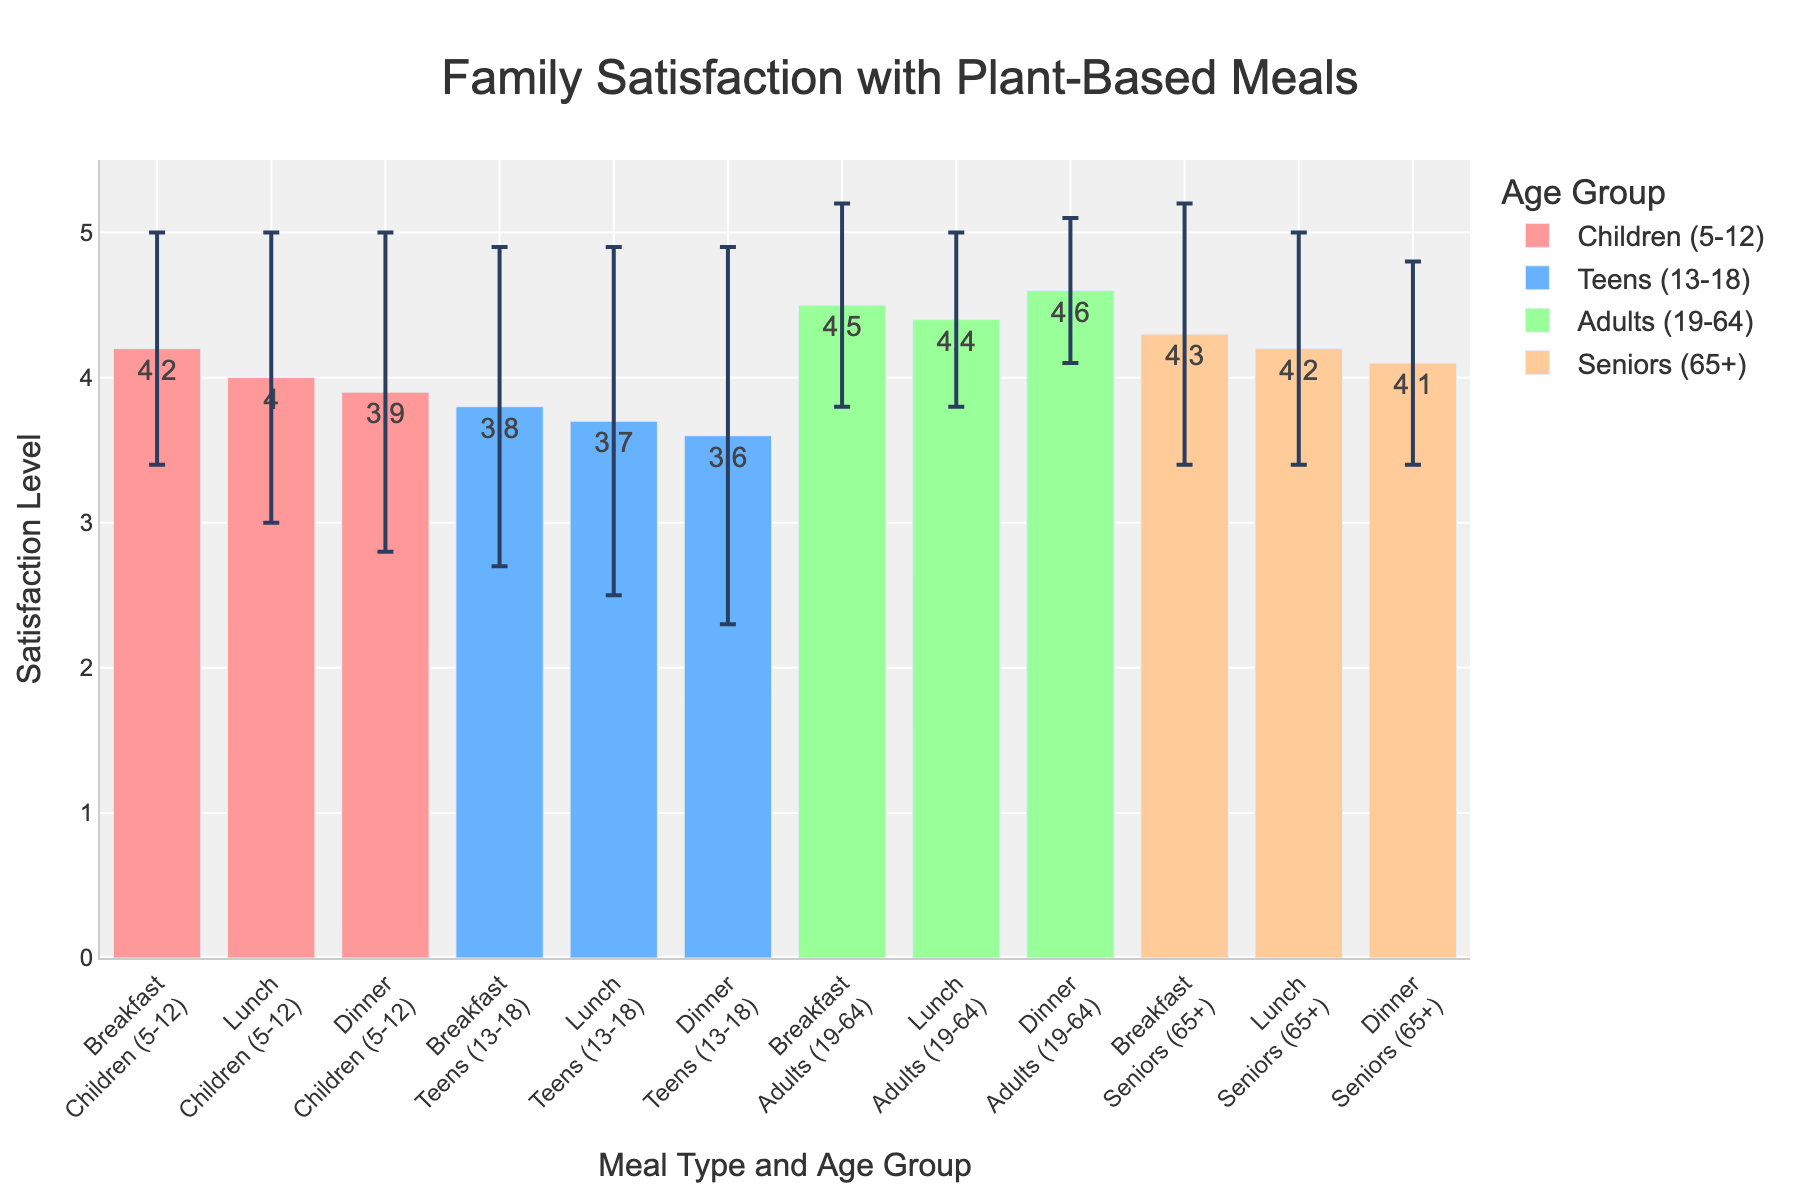What's the title of the figure? The title of the figure is typically displayed at the top.
Answer: Family Satisfaction with Plant-Based Meals Which age group has the highest mean satisfaction for dinner meals? Find the dinner column and the bars representing each age group, and identify the bar with the highest mean satisfaction level.
Answer: Adults (19-64) How does satisfaction with lunch meals compare between teens and seniors? Refer to the lunch meal bars for both age groups and compare their mean satisfaction levels visually. Seniors have a higher satisfaction level than teens.
Answer: Seniors (65+) have higher satisfaction than Teens (13-18) What's the difference in mean satisfaction for breakfast meals between children and adults? Identify the breakfast meal bars for children and adults, and subtract the mean satisfaction of children from that of adults (4.5 - 4.2).
Answer: 0.3 Which meal type shows the highest variability in satisfaction for teens? Variability is reflected by the length of the error bars for each meal type; check which meal type has the longest error bar for teens. Dinner has the highest variability with a standard deviation of 1.3.
Answer: Dinner What is the mean satisfaction level for seniors with lunch meals, and how does this compare to the satisfaction level for seniors with dinner meals? The mean satisfaction levels for lunch and dinner meals for seniors are 4.2 and 4.1, respectively. Compare these two values. The satisfaction level for lunch is slightly higher than for dinner.
Answer: Lunch (4.2) is higher than Dinner (4.1) What is the average satisfaction level across all age groups for breakfast meals? To calculate the average, add the mean satisfaction levels of all age groups for breakfast and divide by the number of age groups (4.2 + 3.8 + 4.5 + 4.3) / 4.
Answer: 4.2 Which meal type and age group have the lowest mean satisfaction level? Identify the combination with the lowest bar height.
Answer: Dinner, Teens (3.6) By how much does the standard deviation of satisfaction differ between breakfast and lunch for adults? Subtract the standard deviations given for breakfast and lunch for adults (0.7 - 0.6).
Answer: 0.1 